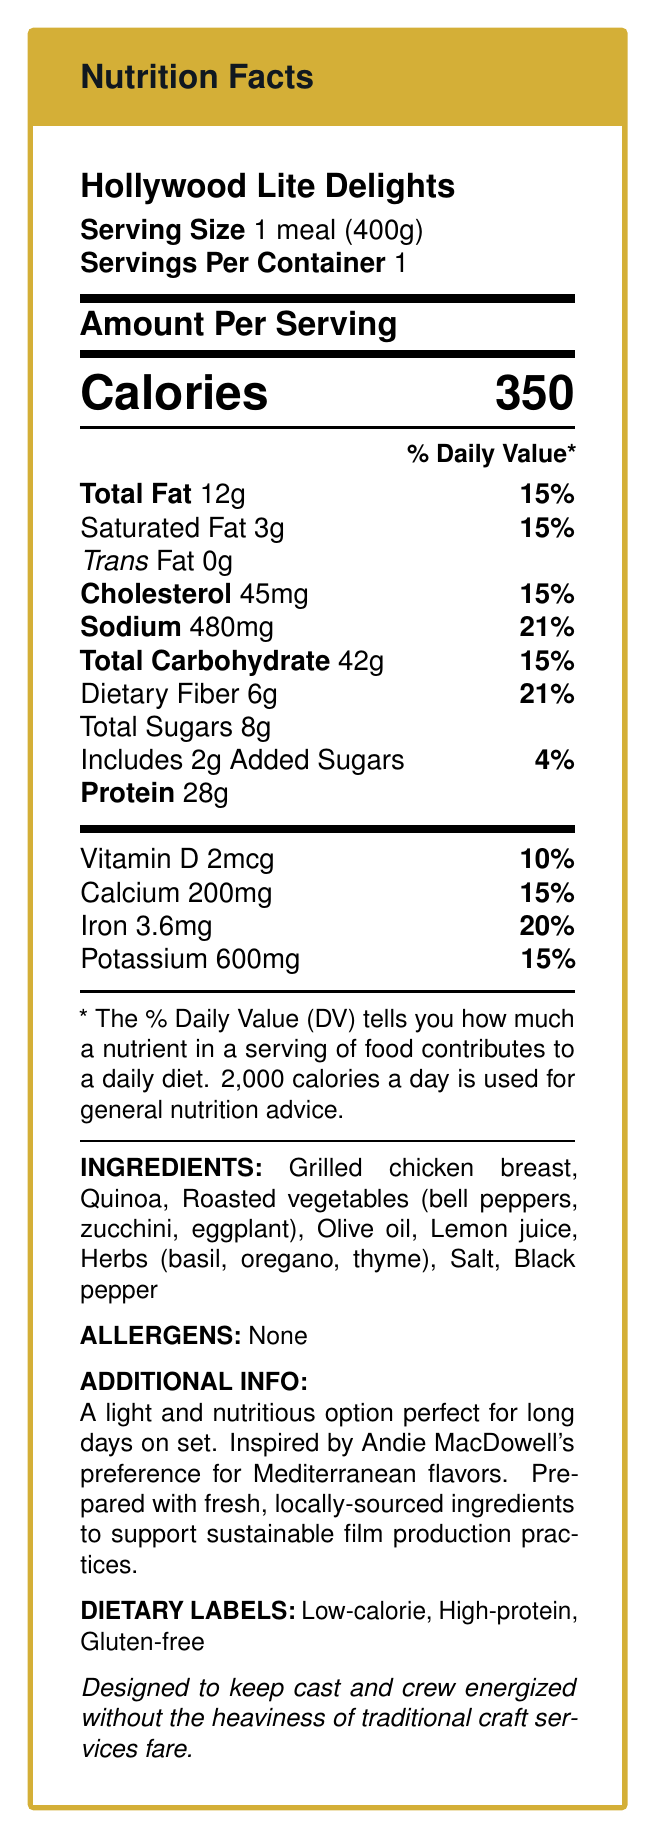who is the meal service intended for? The additional info section states that the meal is designed to keep cast and crew energized on film sets.
Answer: film sets' cast and crew what is the serving size? The serving size is clearly mentioned at the beginning of the document.
Answer: 1 meal (400g) how many calories does one meal contain? The document lists the amount of calories per meal as 350.
Answer: 350 calories what percentage of the daily value for sodium does the meal provide? The document states that the sodium content is 21% of the daily value.
Answer: 21% which ingredient inspired by Andie MacDowell's preference is mentioned? The meal description mentions that it is inspired by Andie MacDowell's preference for Mediterranean flavors.
Answer: Mediterranean flavors which of the following is NOT an ingredient in the meal? A. Grilled chicken breast B. Lemon juice C. Parmesan cheese D. Quinoa The ingredient list does not include Parmesan cheese.
Answer: C. Parmesan cheese what is the protein content? The document states that the meal contains 28g of protein.
Answer: 28g which dietary labels are associated with the meal? A. Low-calorie B. High-protein C. Gluten-free D. All of the above The dietary labels section lists Low-calorie, High-protein, and Gluten-free.
Answer: D. All of the above is any allergen listed in the document? The allergens section states "None".
Answer: No summarize the main idea of the document. The document serves as a comprehensive guide to the nutritional content and purpose of the meal, focusing on its benefits for film industry professionals.
Answer: The document is a Nutrition Facts Label for "Hollywood Lite Delights," a gourmet meal designed for film sets featuring low-calorie, high-protein, and gluten-free options. It provides detailed nutritional information, ingredient list, and highlights its suitability for keeping the cast and crew energized. The meal is inspired by Mediterranean flavors preferred by Andie MacDowell and uses fresh, locally-sourced ingredients. what is the exact number of vitamins listed in the document? The document only lists Vitamin D but does not provide an exhaustive list of all the vitamins included.
Answer: Cannot be determined 